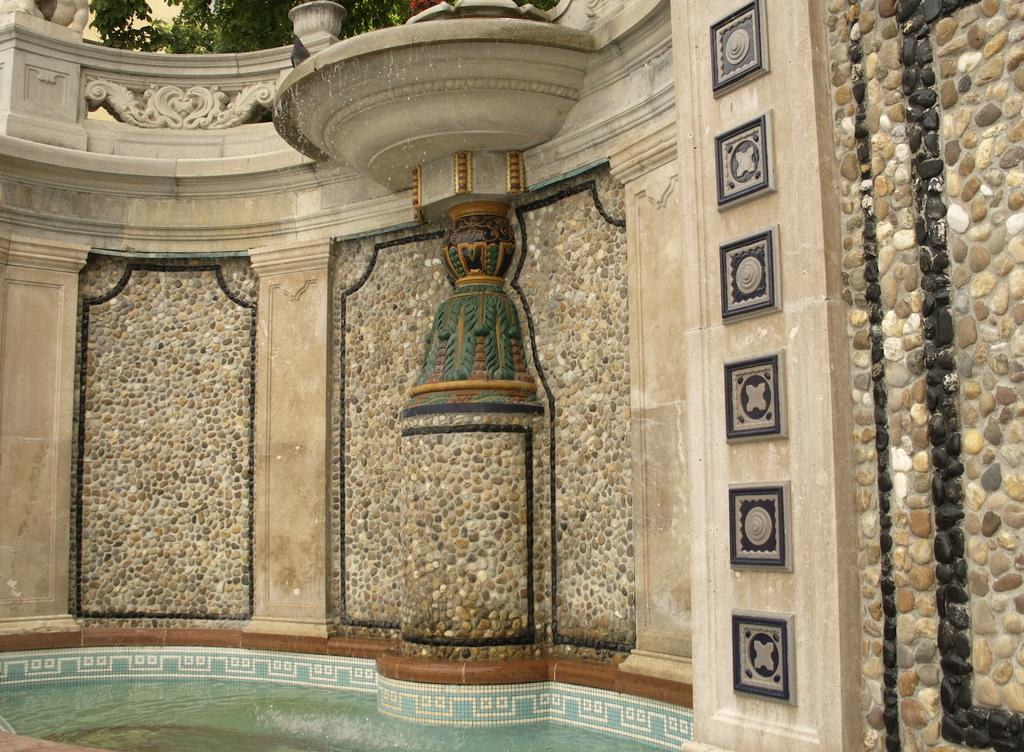What type of design can be seen on the wall in the image? There is a designed wall in the image. What other elements are present in the image besides the designed wall? There are plants and water visible in the image. How many ears of corn are visible in the image? There is no corn present in the image. What type of ornament is hanging from the designed wall in the image? There is no ornament mentioned or visible in the image. 